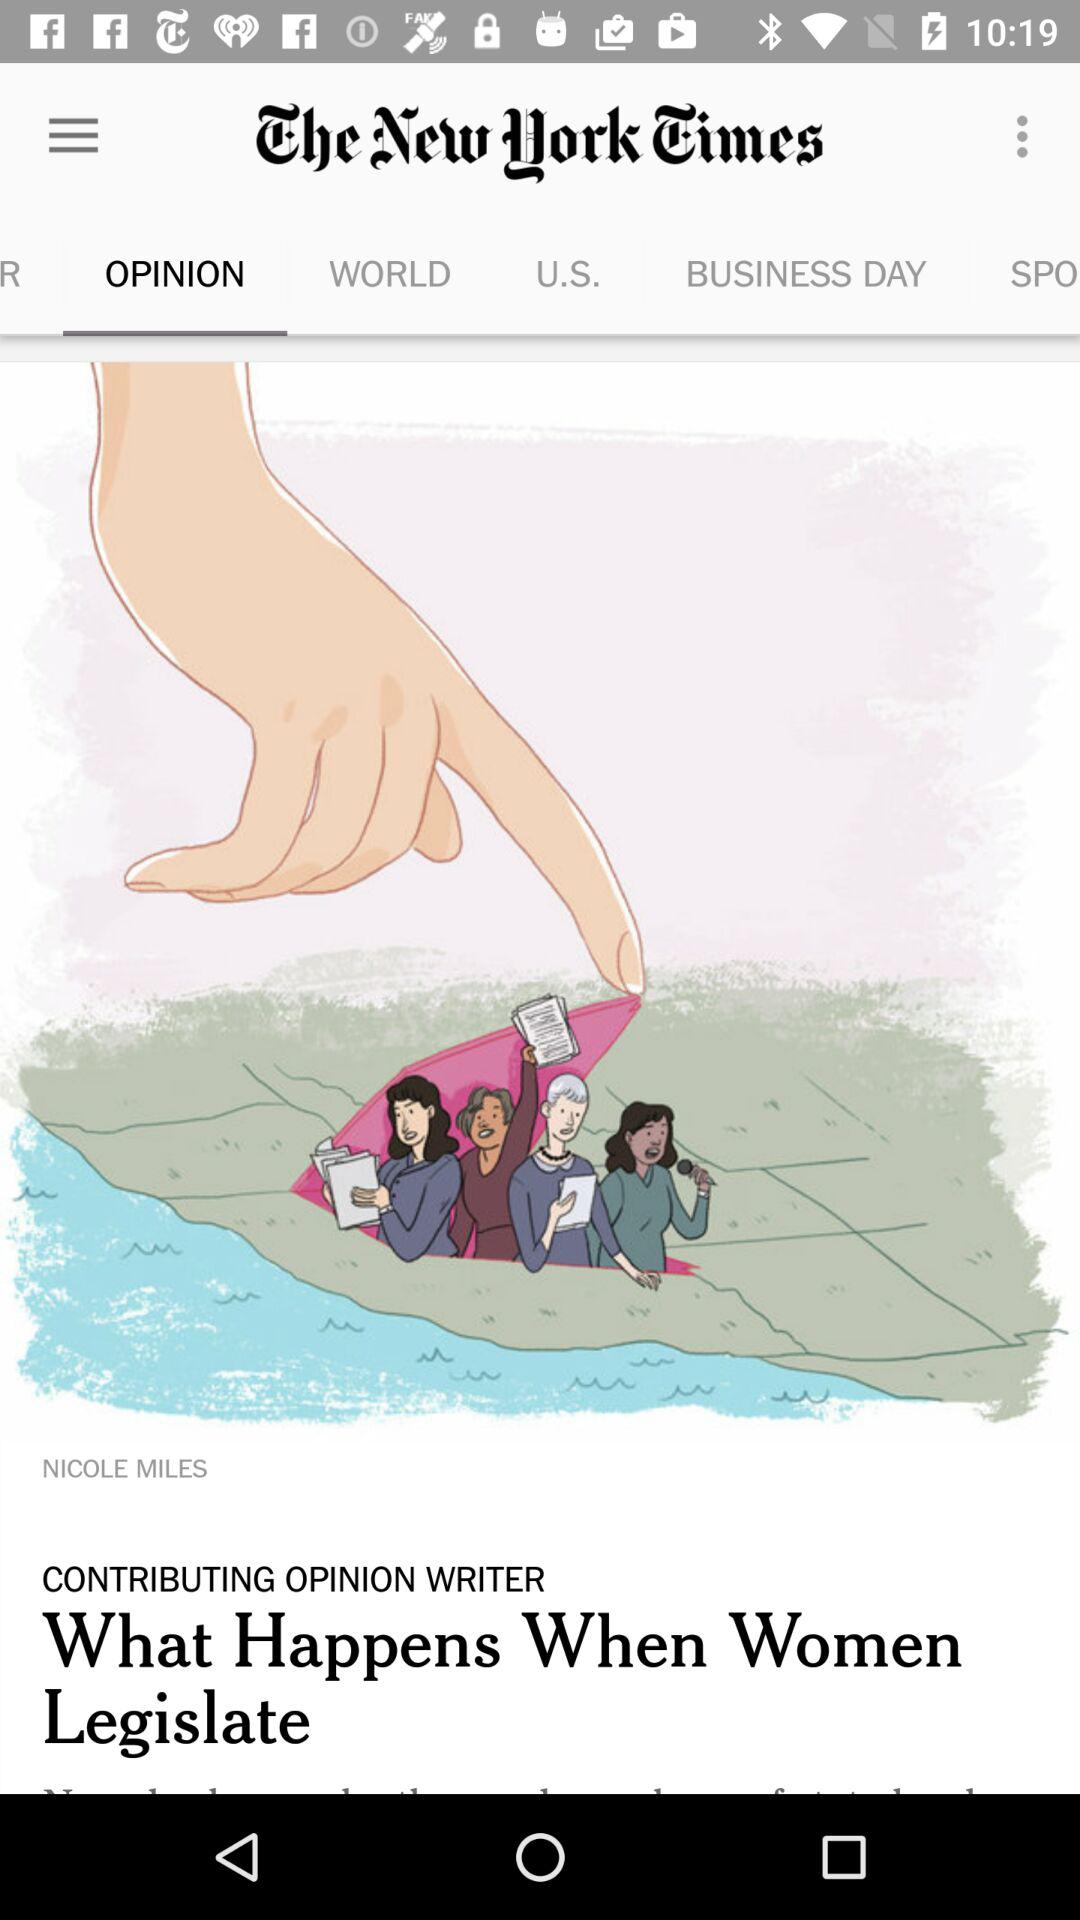What is the name of the application? The name of the application is "The New York Times". 